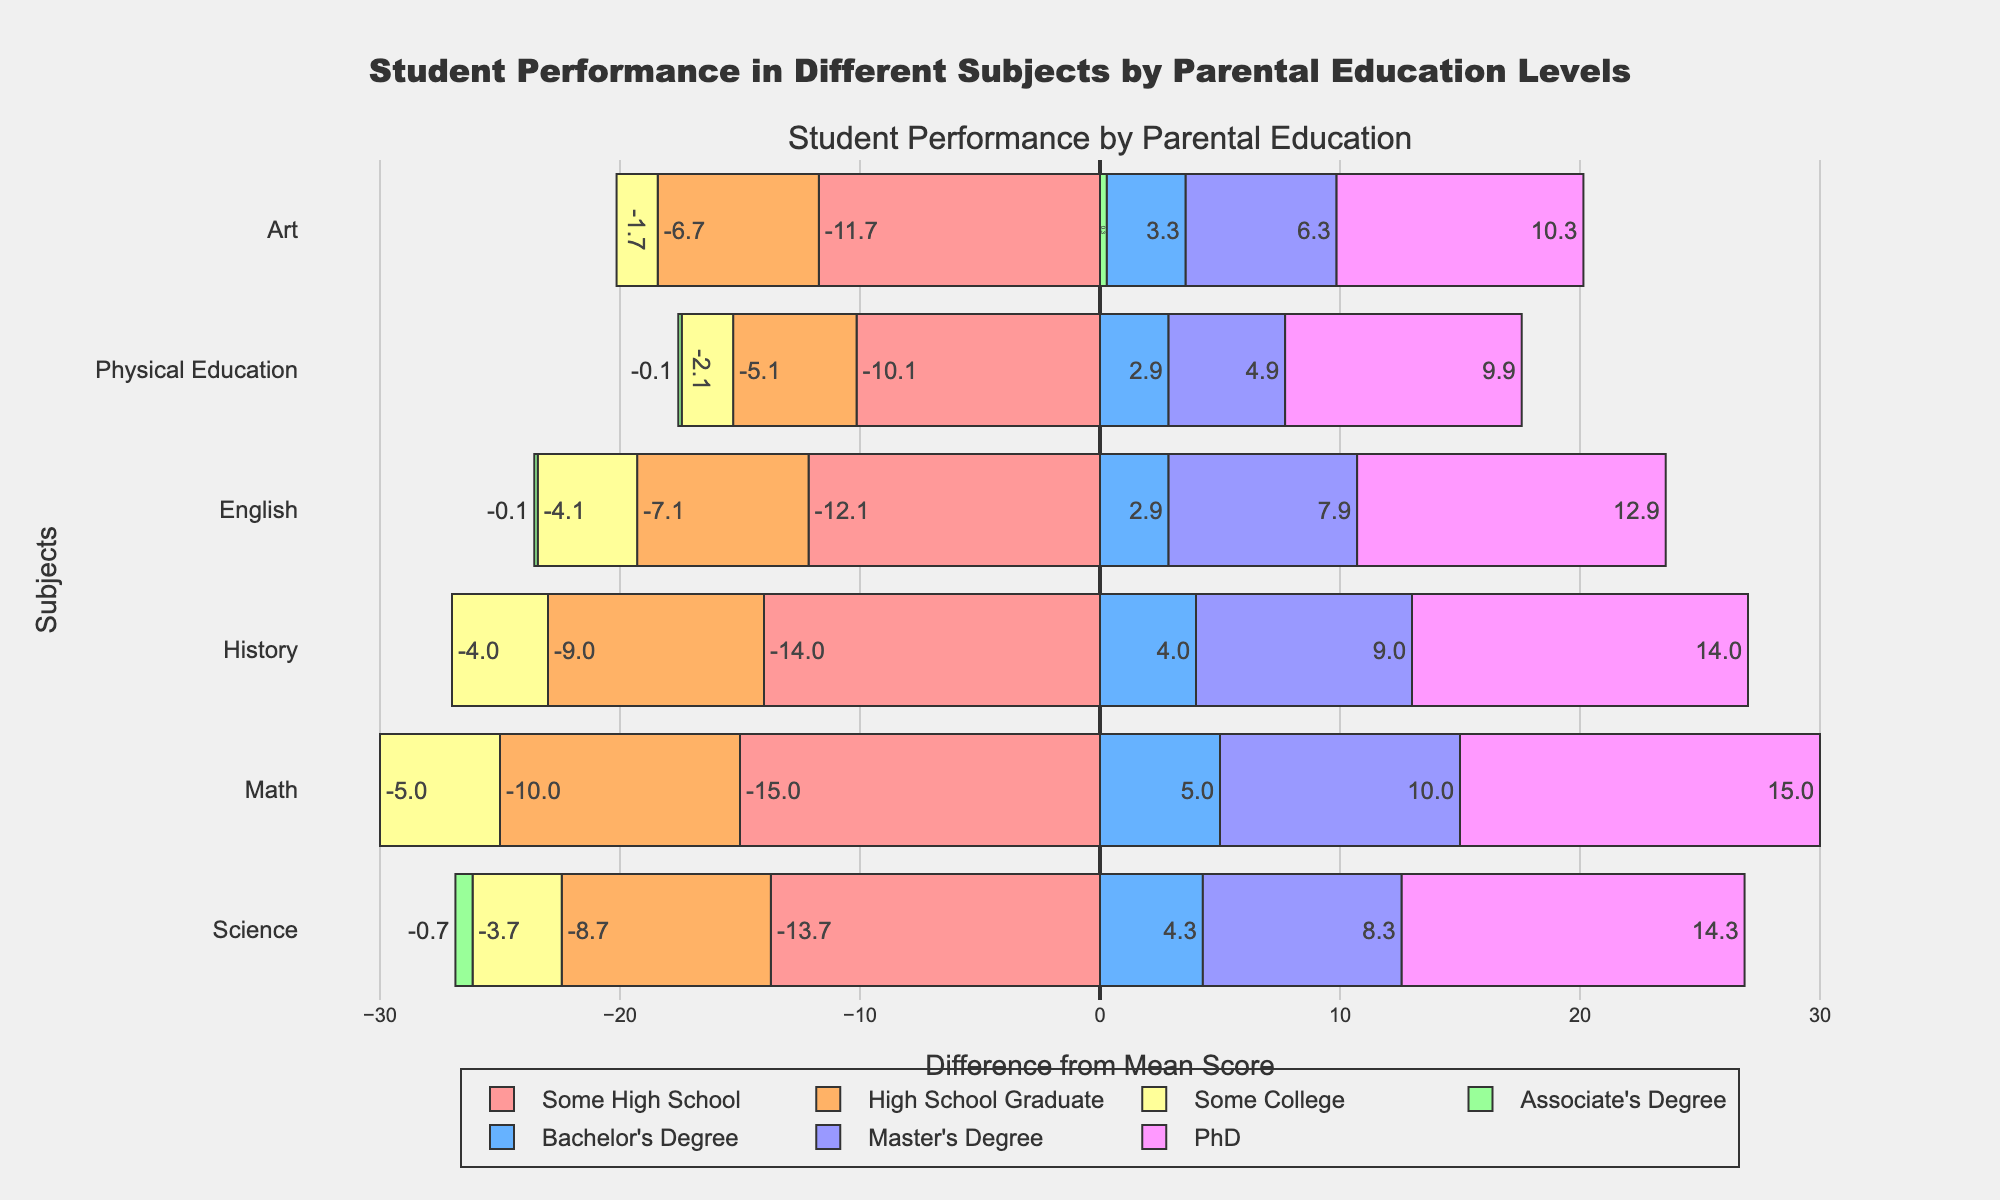What subject has the highest performance improvement with higher parental education? To determine this, observe the bars and focus on the increment in scores from "Some High School" to "PhD". Art shows a clear and consistent increase, rising from 60 to 82, indicating the biggest improvement.
Answer: Art Which parental education level shows the most consistent performance across all subjects? Look at the overall divergence of the bars for each education level. The "PhD" level shows the least variation in bar lengths across subjects, indicating the most consistent performance.
Answer: PhD Which subject shows the least divergence from the mean for the "Some College" parental education level? Focus on the "Some College" bars and compare their differences from the mean for each subject. English has the smallest deviation, close to zero.
Answer: English Which parental education level has the lowest performance in Science? Observe the bars for Science and identify the lowest value. The "Some High School" level shows the lowest performance with a bar indicating a score of 50.
Answer: Some High School By how much does the average performance in Math improve from "High School Graduate" to "Bachelor's Degree"? First, find the Math scores for the given education levels (50 for "High School Graduate" and 65 for "Bachelor's Degree"). The improvement is 65 - 50 = 15.
Answer: 15 Which subject has the most variation in performance based on parental education level? Look at the length of the bars for each subject. Physical Education has the widest range, going from 70 to 90, indicating the most variation.
Answer: Physical Education 